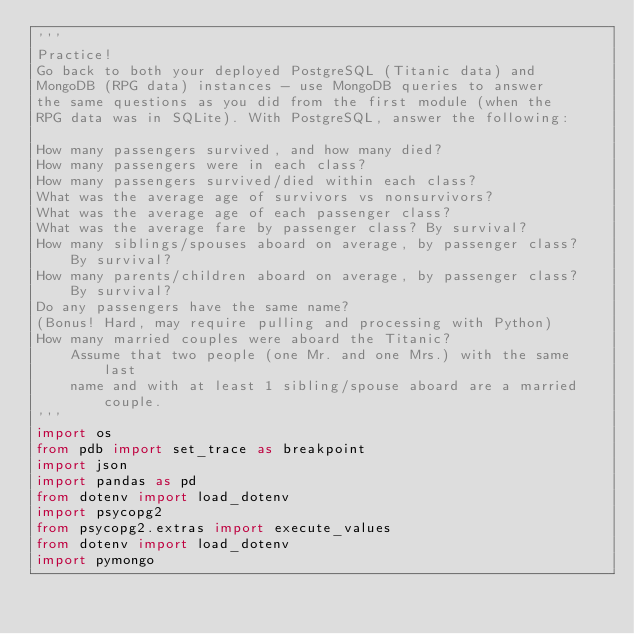Convert code to text. <code><loc_0><loc_0><loc_500><loc_500><_Python_>'''
Practice! 
Go back to both your deployed PostgreSQL (Titanic data) and 
MongoDB (RPG data) instances - use MongoDB queries to answer 
the same questions as you did from the first module (when the 
RPG data was in SQLite). With PostgreSQL, answer the following:

How many passengers survived, and how many died?
How many passengers were in each class?
How many passengers survived/died within each class?
What was the average age of survivors vs nonsurvivors?
What was the average age of each passenger class?
What was the average fare by passenger class? By survival?
How many siblings/spouses aboard on average, by passenger class? 
    By survival?
How many parents/children aboard on average, by passenger class? 
    By survival?
Do any passengers have the same name?
(Bonus! Hard, may require pulling and processing with Python) 
How many married couples were aboard the Titanic? 
    Assume that two people (one Mr. and one Mrs.) with the same last 
    name and with at least 1 sibling/spouse aboard are a married couple.
'''
import os
from pdb import set_trace as breakpoint
import json
import pandas as pd
from dotenv import load_dotenv
import psycopg2
from psycopg2.extras import execute_values
from dotenv import load_dotenv
import pymongo

</code> 